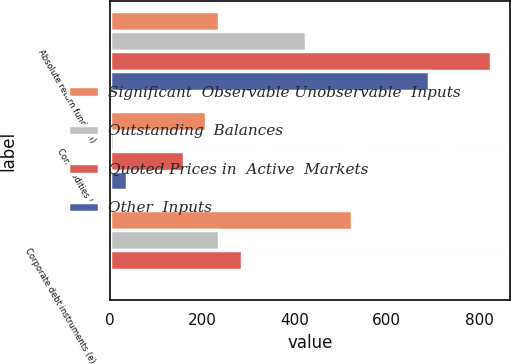Convert chart to OTSL. <chart><loc_0><loc_0><loc_500><loc_500><stacked_bar_chart><ecel><fcel>Absolute return funds (h)<fcel>Commodities (i)<fcel>Corporate debt instruments (e)<nl><fcel>Significant  Observable Unobservable  Inputs<fcel>237<fcel>208<fcel>524<nl><fcel>Outstanding  Balances<fcel>425<fcel>9<fcel>237<nl><fcel>Quoted Prices in  Active  Markets<fcel>825<fcel>161<fcel>286<nl><fcel>Other  Inputs<fcel>691<fcel>38<fcel>1<nl></chart> 